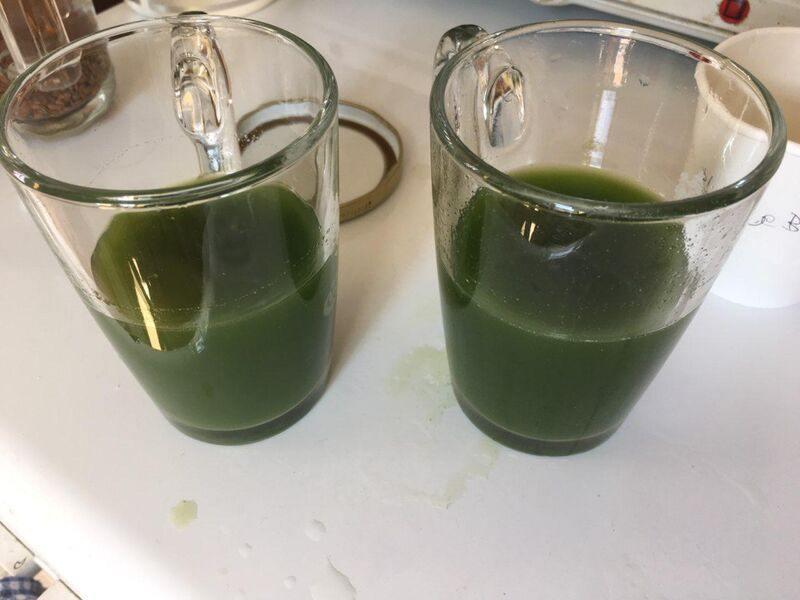What might have caused the spillage on the countertop? The spillage on the countertop likely occurred during the process of pouring or transferring the green liquid into the mugs. This could have happened if the person pouring the liquid was aiming to fill both mugs to a similar level, resulting in an overflow from the left mug first, nearly filling it to the brim, and then pouring less precisely into the right mug, which has a lower liquid level. Additionally, moving the mugs while they are full of liquid could also result in spillage if the liquid sloshes over the side. Notably, the bubble in the left mug indicates recent movement or pouring, strengthening the idea that an inadvertent pour-related issue caused the spill. 